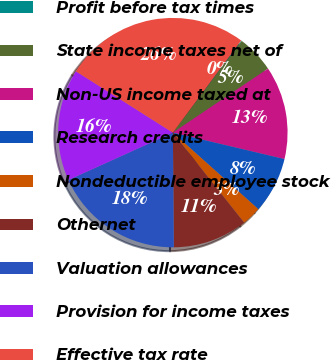<chart> <loc_0><loc_0><loc_500><loc_500><pie_chart><fcel>Profit before tax times<fcel>State income taxes net of<fcel>Non-US income taxed at<fcel>Research credits<fcel>Nondeductible employee stock<fcel>Othernet<fcel>Valuation allowances<fcel>Provision for income taxes<fcel>Effective tax rate<nl><fcel>0.1%<fcel>5.31%<fcel>13.14%<fcel>7.92%<fcel>2.71%<fcel>10.53%<fcel>18.36%<fcel>15.75%<fcel>26.18%<nl></chart> 